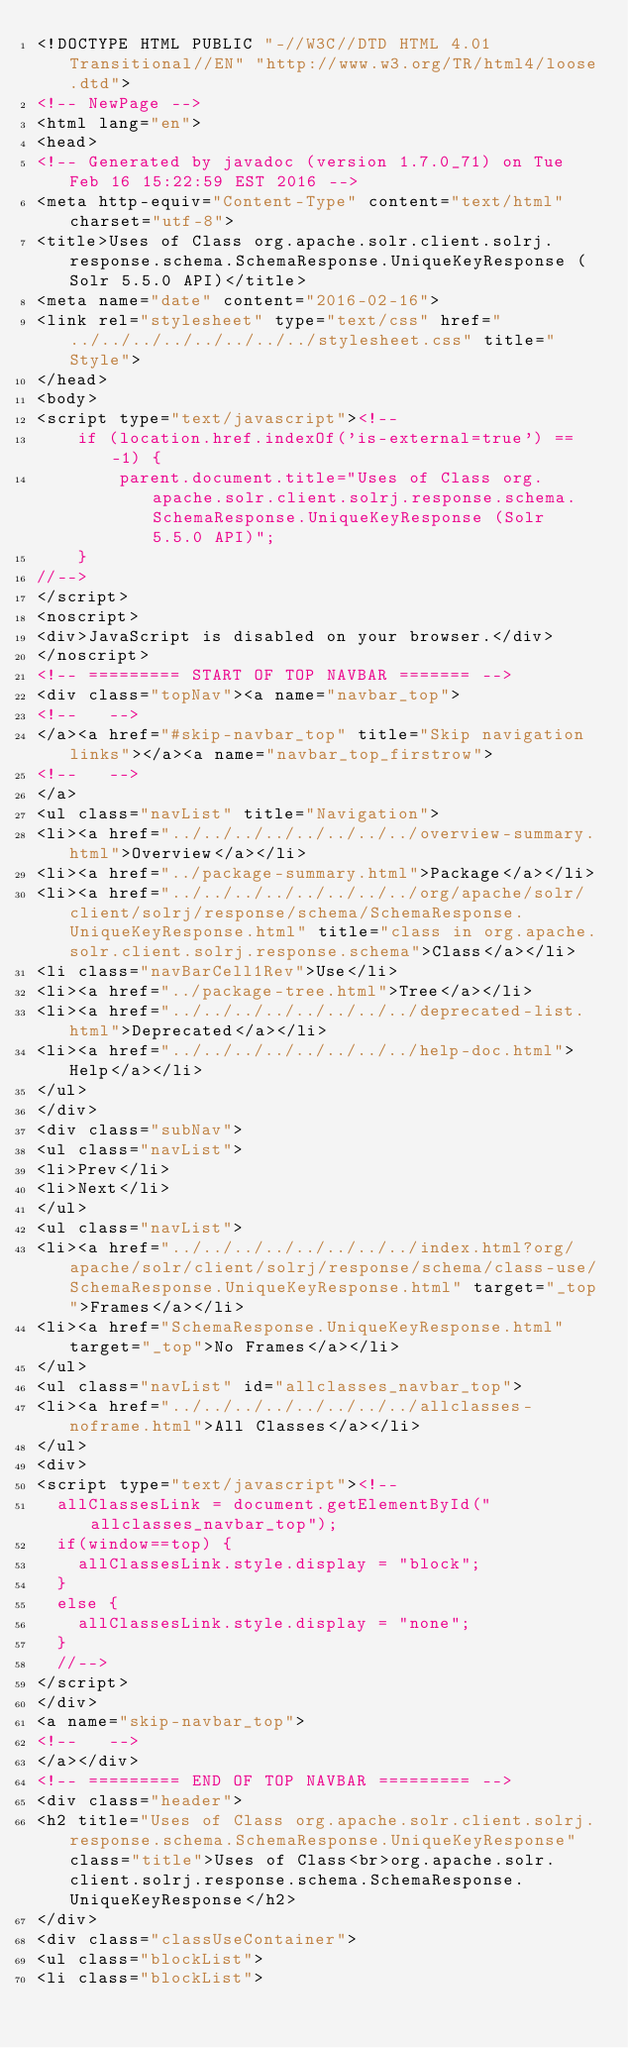Convert code to text. <code><loc_0><loc_0><loc_500><loc_500><_HTML_><!DOCTYPE HTML PUBLIC "-//W3C//DTD HTML 4.01 Transitional//EN" "http://www.w3.org/TR/html4/loose.dtd">
<!-- NewPage -->
<html lang="en">
<head>
<!-- Generated by javadoc (version 1.7.0_71) on Tue Feb 16 15:22:59 EST 2016 -->
<meta http-equiv="Content-Type" content="text/html" charset="utf-8">
<title>Uses of Class org.apache.solr.client.solrj.response.schema.SchemaResponse.UniqueKeyResponse (Solr 5.5.0 API)</title>
<meta name="date" content="2016-02-16">
<link rel="stylesheet" type="text/css" href="../../../../../../../../stylesheet.css" title="Style">
</head>
<body>
<script type="text/javascript"><!--
    if (location.href.indexOf('is-external=true') == -1) {
        parent.document.title="Uses of Class org.apache.solr.client.solrj.response.schema.SchemaResponse.UniqueKeyResponse (Solr 5.5.0 API)";
    }
//-->
</script>
<noscript>
<div>JavaScript is disabled on your browser.</div>
</noscript>
<!-- ========= START OF TOP NAVBAR ======= -->
<div class="topNav"><a name="navbar_top">
<!--   -->
</a><a href="#skip-navbar_top" title="Skip navigation links"></a><a name="navbar_top_firstrow">
<!--   -->
</a>
<ul class="navList" title="Navigation">
<li><a href="../../../../../../../../overview-summary.html">Overview</a></li>
<li><a href="../package-summary.html">Package</a></li>
<li><a href="../../../../../../../../org/apache/solr/client/solrj/response/schema/SchemaResponse.UniqueKeyResponse.html" title="class in org.apache.solr.client.solrj.response.schema">Class</a></li>
<li class="navBarCell1Rev">Use</li>
<li><a href="../package-tree.html">Tree</a></li>
<li><a href="../../../../../../../../deprecated-list.html">Deprecated</a></li>
<li><a href="../../../../../../../../help-doc.html">Help</a></li>
</ul>
</div>
<div class="subNav">
<ul class="navList">
<li>Prev</li>
<li>Next</li>
</ul>
<ul class="navList">
<li><a href="../../../../../../../../index.html?org/apache/solr/client/solrj/response/schema/class-use/SchemaResponse.UniqueKeyResponse.html" target="_top">Frames</a></li>
<li><a href="SchemaResponse.UniqueKeyResponse.html" target="_top">No Frames</a></li>
</ul>
<ul class="navList" id="allclasses_navbar_top">
<li><a href="../../../../../../../../allclasses-noframe.html">All Classes</a></li>
</ul>
<div>
<script type="text/javascript"><!--
  allClassesLink = document.getElementById("allclasses_navbar_top");
  if(window==top) {
    allClassesLink.style.display = "block";
  }
  else {
    allClassesLink.style.display = "none";
  }
  //-->
</script>
</div>
<a name="skip-navbar_top">
<!--   -->
</a></div>
<!-- ========= END OF TOP NAVBAR ========= -->
<div class="header">
<h2 title="Uses of Class org.apache.solr.client.solrj.response.schema.SchemaResponse.UniqueKeyResponse" class="title">Uses of Class<br>org.apache.solr.client.solrj.response.schema.SchemaResponse.UniqueKeyResponse</h2>
</div>
<div class="classUseContainer">
<ul class="blockList">
<li class="blockList"></code> 